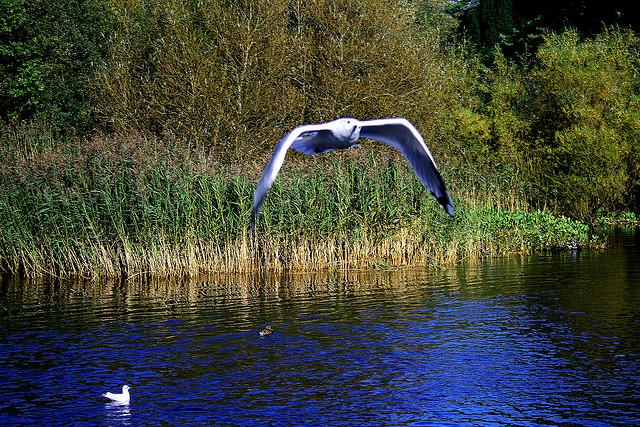Is the bird flying?
Keep it brief. Yes. Does it look close to dark?
Give a very brief answer. No. What color is the bird?
Concise answer only. White. Are these birds often found near the ocean?
Short answer required. Yes. What color is the bird's eye?
Be succinct. Black. Is this a winter scene?
Give a very brief answer. No. What color is the water?
Concise answer only. Blue. How many animals are there?
Short answer required. 3. 